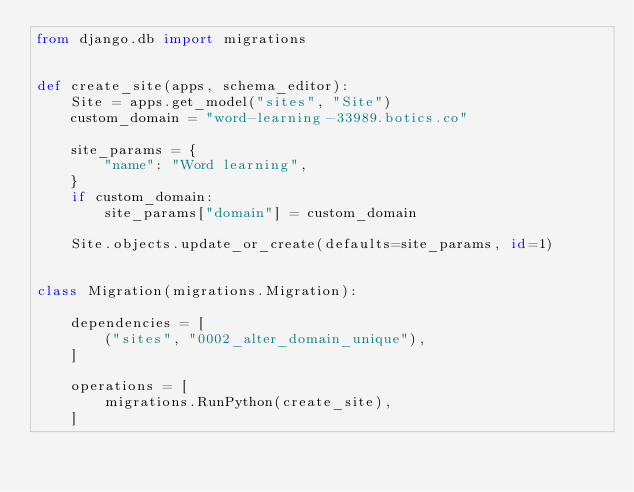<code> <loc_0><loc_0><loc_500><loc_500><_Python_>from django.db import migrations


def create_site(apps, schema_editor):
    Site = apps.get_model("sites", "Site")
    custom_domain = "word-learning-33989.botics.co"

    site_params = {
        "name": "Word learning",
    }
    if custom_domain:
        site_params["domain"] = custom_domain

    Site.objects.update_or_create(defaults=site_params, id=1)


class Migration(migrations.Migration):

    dependencies = [
        ("sites", "0002_alter_domain_unique"),
    ]

    operations = [
        migrations.RunPython(create_site),
    ]
</code> 